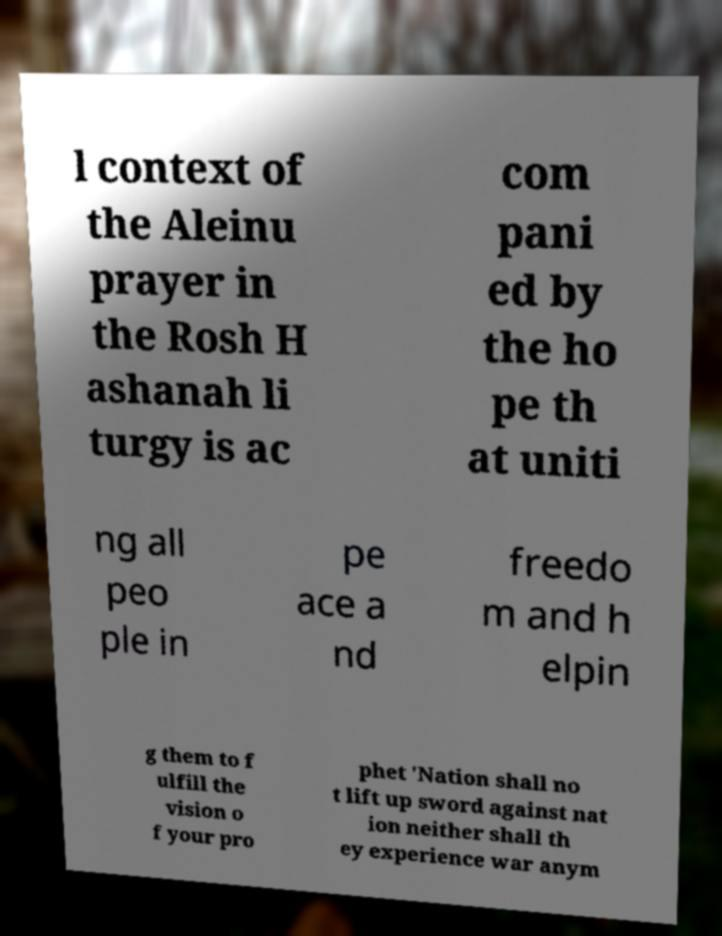Can you accurately transcribe the text from the provided image for me? l context of the Aleinu prayer in the Rosh H ashanah li turgy is ac com pani ed by the ho pe th at uniti ng all peo ple in pe ace a nd freedo m and h elpin g them to f ulfill the vision o f your pro phet 'Nation shall no t lift up sword against nat ion neither shall th ey experience war anym 